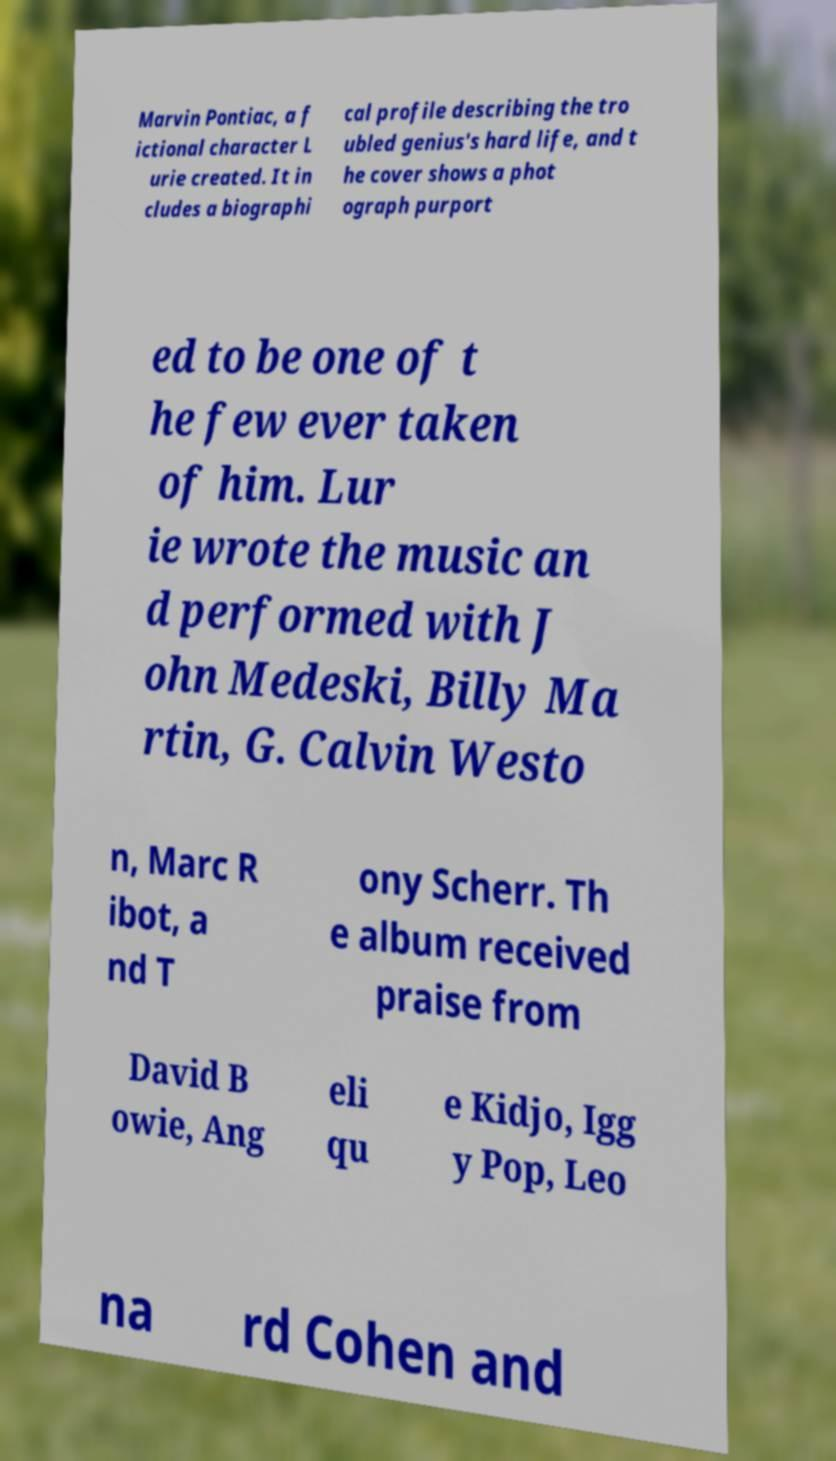For documentation purposes, I need the text within this image transcribed. Could you provide that? Marvin Pontiac, a f ictional character L urie created. It in cludes a biographi cal profile describing the tro ubled genius's hard life, and t he cover shows a phot ograph purport ed to be one of t he few ever taken of him. Lur ie wrote the music an d performed with J ohn Medeski, Billy Ma rtin, G. Calvin Westo n, Marc R ibot, a nd T ony Scherr. Th e album received praise from David B owie, Ang eli qu e Kidjo, Igg y Pop, Leo na rd Cohen and 